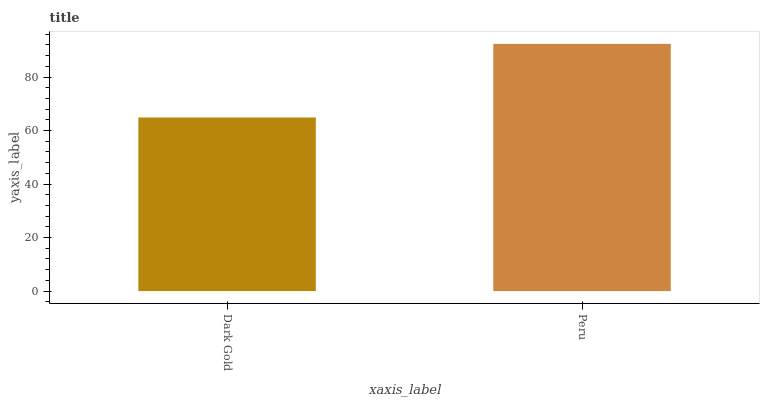Is Dark Gold the minimum?
Answer yes or no. Yes. Is Peru the maximum?
Answer yes or no. Yes. Is Peru the minimum?
Answer yes or no. No. Is Peru greater than Dark Gold?
Answer yes or no. Yes. Is Dark Gold less than Peru?
Answer yes or no. Yes. Is Dark Gold greater than Peru?
Answer yes or no. No. Is Peru less than Dark Gold?
Answer yes or no. No. Is Peru the high median?
Answer yes or no. Yes. Is Dark Gold the low median?
Answer yes or no. Yes. Is Dark Gold the high median?
Answer yes or no. No. Is Peru the low median?
Answer yes or no. No. 